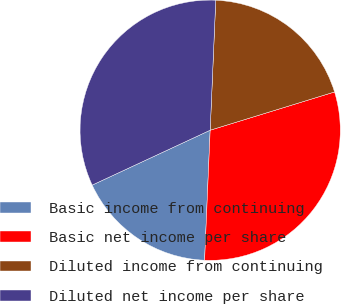Convert chart. <chart><loc_0><loc_0><loc_500><loc_500><pie_chart><fcel>Basic income from continuing<fcel>Basic net income per share<fcel>Diluted income from continuing<fcel>Diluted net income per share<nl><fcel>17.39%<fcel>30.43%<fcel>19.57%<fcel>32.61%<nl></chart> 